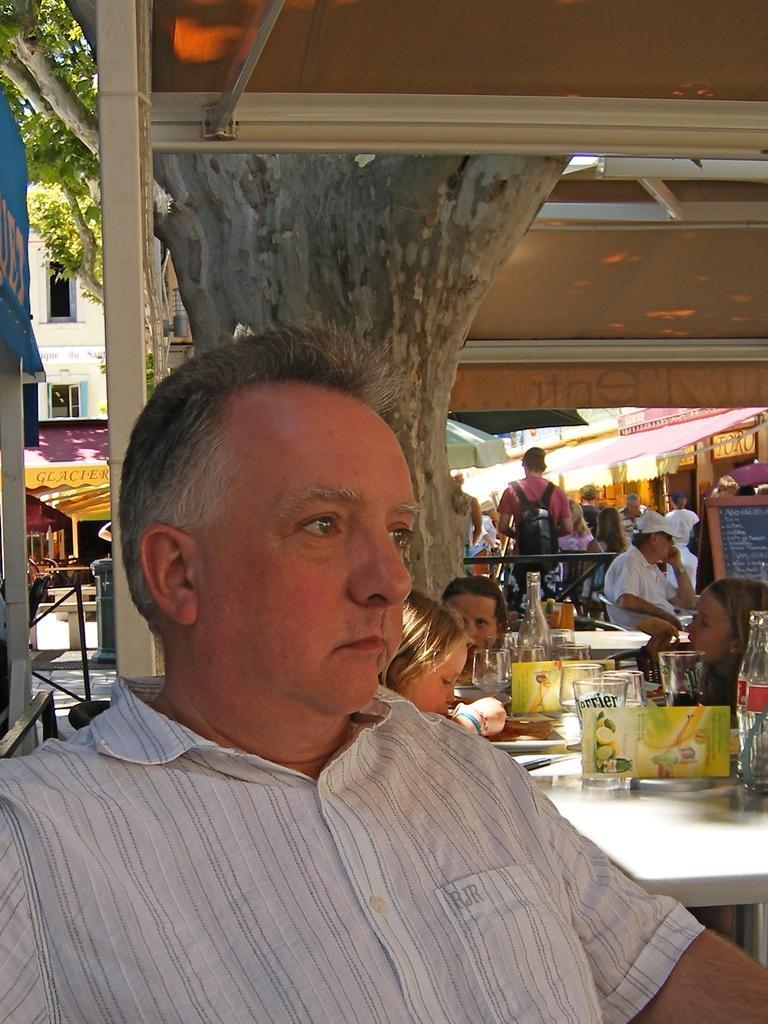Describe this image in one or two sentences. In this picture we can see a group of people, here we can see tables, glasses, bottles, name board, tents, trees, some objects and in the background we can see a building. 